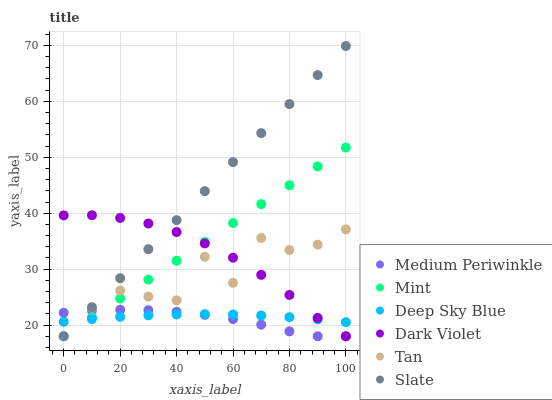Does Medium Periwinkle have the minimum area under the curve?
Answer yes or no. Yes. Does Slate have the maximum area under the curve?
Answer yes or no. Yes. Does Dark Violet have the minimum area under the curve?
Answer yes or no. No. Does Dark Violet have the maximum area under the curve?
Answer yes or no. No. Is Slate the smoothest?
Answer yes or no. Yes. Is Tan the roughest?
Answer yes or no. Yes. Is Medium Periwinkle the smoothest?
Answer yes or no. No. Is Medium Periwinkle the roughest?
Answer yes or no. No. Does Slate have the lowest value?
Answer yes or no. Yes. Does Deep Sky Blue have the lowest value?
Answer yes or no. No. Does Slate have the highest value?
Answer yes or no. Yes. Does Medium Periwinkle have the highest value?
Answer yes or no. No. Does Tan intersect Dark Violet?
Answer yes or no. Yes. Is Tan less than Dark Violet?
Answer yes or no. No. Is Tan greater than Dark Violet?
Answer yes or no. No. 